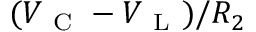<formula> <loc_0><loc_0><loc_500><loc_500>( V _ { C } - V _ { L } ) / R _ { 2 }</formula> 